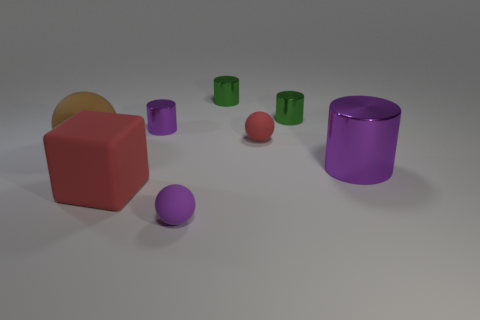Can you tell me more about the different shapes in the image? Certainly! The image displays a variety of geometric shapes arranged randomly. We have a large red cube, a big purple cylinder, a small purple sphere, multiple small green cylinders of various sizes, and a flat circular object that seems to be partially obscured by the purple cylinder. Their distinct forms and placements make for an interesting study in geometry and spatial relationships.  What emotions do the colors and arrangement of these objects evoke? The colors in the image—vibrant reds, purples, and greens—set against a neutral background evoke a playful and creative atmosphere. The random arrangement of the objects with different shapes and sizes suggests a sense of freedom and whimsy, as if inviting viewers to engage with the elements in a lighthearted exploration of color and form. 